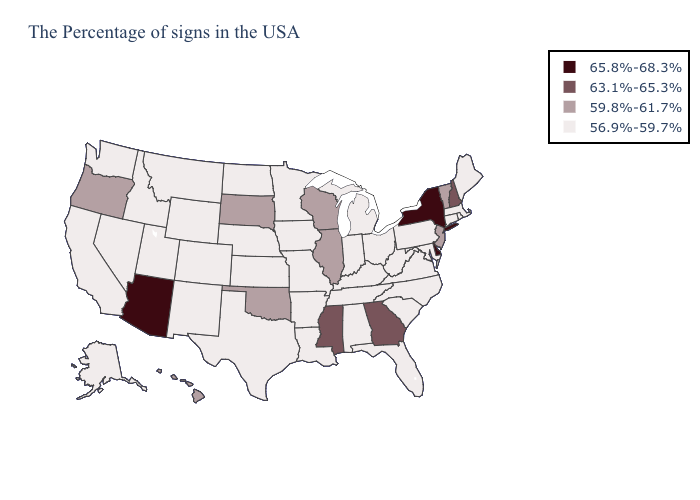Name the states that have a value in the range 65.8%-68.3%?
Short answer required. New York, Delaware, Arizona. Name the states that have a value in the range 63.1%-65.3%?
Be succinct. New Hampshire, Georgia, Mississippi. Name the states that have a value in the range 65.8%-68.3%?
Give a very brief answer. New York, Delaware, Arizona. Name the states that have a value in the range 59.8%-61.7%?
Answer briefly. Vermont, New Jersey, Wisconsin, Illinois, Oklahoma, South Dakota, Oregon, Hawaii. Does Idaho have the same value as Hawaii?
Keep it brief. No. What is the value of Missouri?
Write a very short answer. 56.9%-59.7%. Which states have the lowest value in the MidWest?
Keep it brief. Ohio, Michigan, Indiana, Missouri, Minnesota, Iowa, Kansas, Nebraska, North Dakota. Among the states that border Indiana , does Ohio have the highest value?
Concise answer only. No. Name the states that have a value in the range 59.8%-61.7%?
Keep it brief. Vermont, New Jersey, Wisconsin, Illinois, Oklahoma, South Dakota, Oregon, Hawaii. Name the states that have a value in the range 63.1%-65.3%?
Quick response, please. New Hampshire, Georgia, Mississippi. What is the value of Idaho?
Short answer required. 56.9%-59.7%. Which states have the highest value in the USA?
Short answer required. New York, Delaware, Arizona. Name the states that have a value in the range 59.8%-61.7%?
Concise answer only. Vermont, New Jersey, Wisconsin, Illinois, Oklahoma, South Dakota, Oregon, Hawaii. Does California have the same value as Michigan?
Write a very short answer. Yes. Name the states that have a value in the range 65.8%-68.3%?
Keep it brief. New York, Delaware, Arizona. 